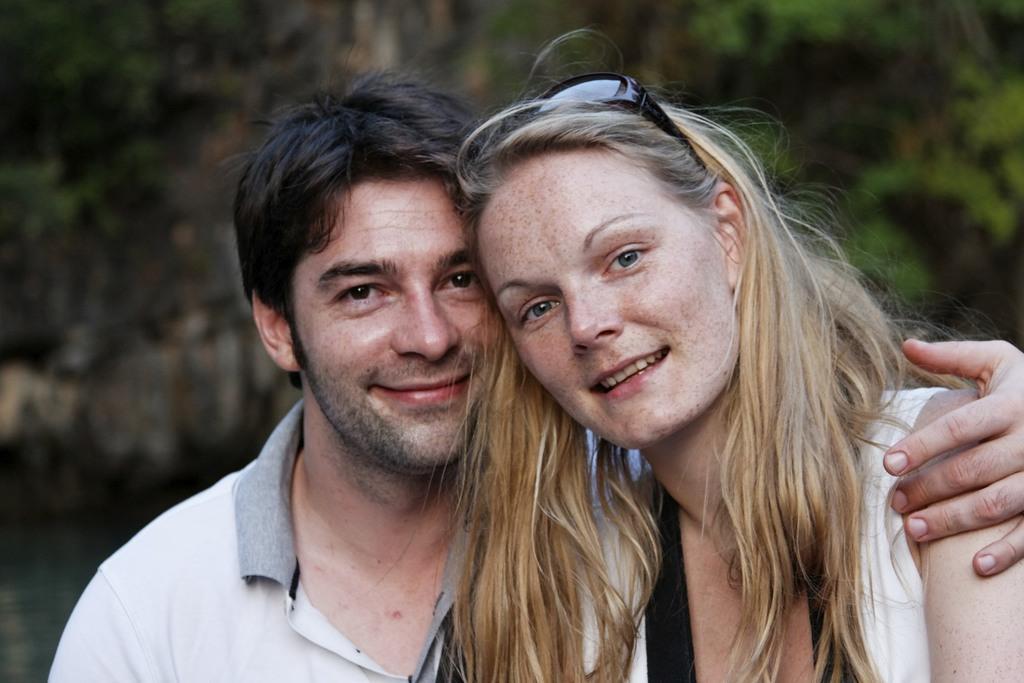Describe this image in one or two sentences. In this image in the foreground I can see two people, one man on the left side and one woman on the right side. 